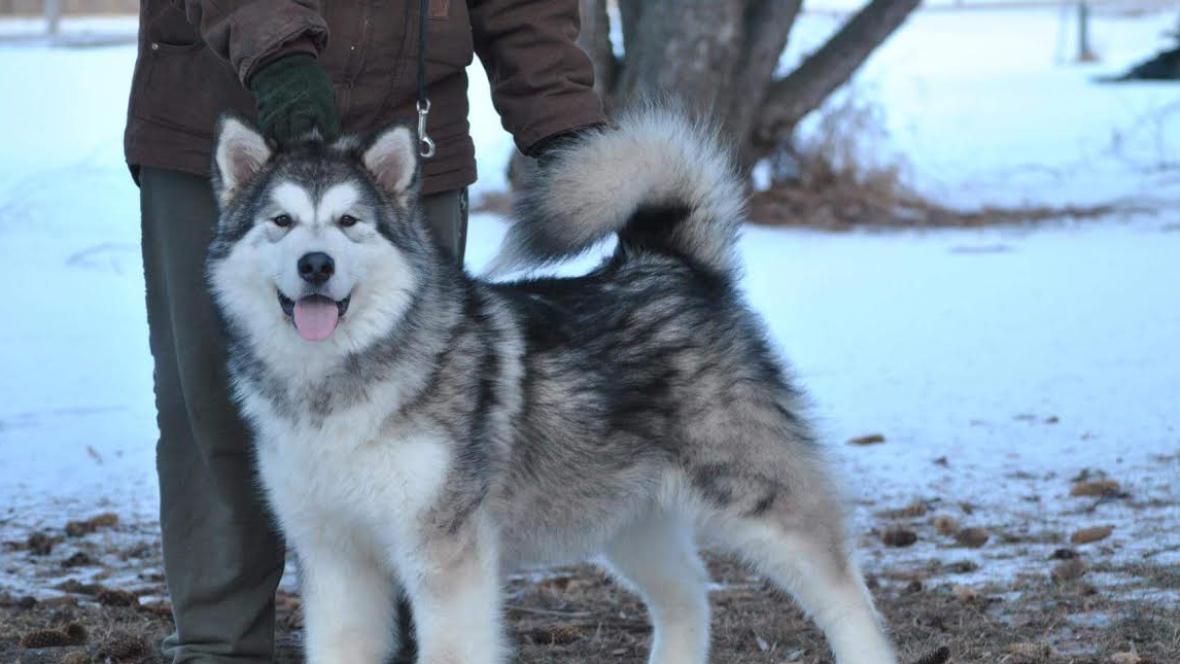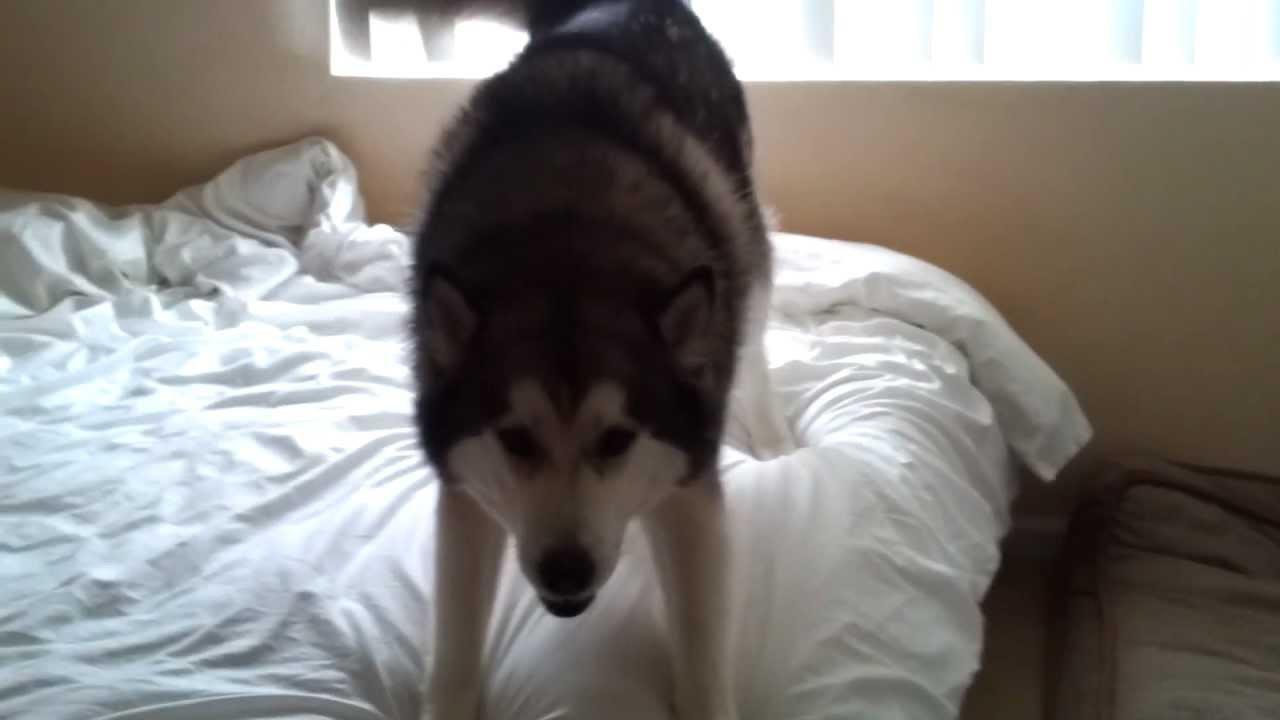The first image is the image on the left, the second image is the image on the right. Given the left and right images, does the statement "The left image features a dog with an open mouth standing in profile in front of someone standing wearing pants." hold true? Answer yes or no. Yes. The first image is the image on the left, the second image is the image on the right. Analyze the images presented: Is the assertion "The dogs in both pictures are looking to the right." valid? Answer yes or no. No. 